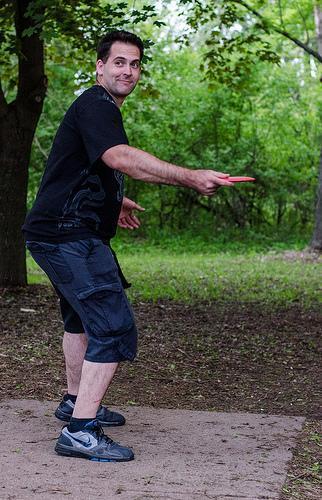How many people in the picture?
Give a very brief answer. 1. 